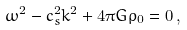Convert formula to latex. <formula><loc_0><loc_0><loc_500><loc_500>\omega ^ { 2 } - c _ { s } ^ { 2 } k ^ { 2 } + 4 \pi G \rho _ { 0 } = 0 \, ,</formula> 